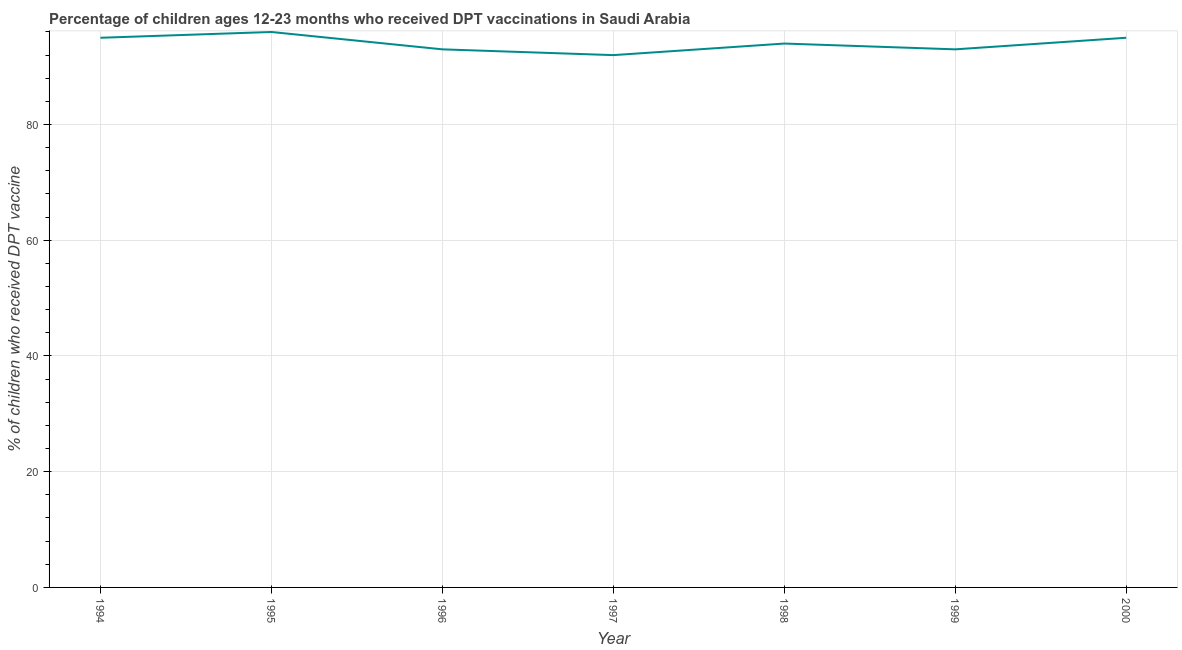What is the percentage of children who received dpt vaccine in 1998?
Your answer should be compact. 94. Across all years, what is the maximum percentage of children who received dpt vaccine?
Your answer should be compact. 96. Across all years, what is the minimum percentage of children who received dpt vaccine?
Provide a succinct answer. 92. In which year was the percentage of children who received dpt vaccine maximum?
Your answer should be compact. 1995. What is the sum of the percentage of children who received dpt vaccine?
Offer a very short reply. 658. What is the difference between the percentage of children who received dpt vaccine in 1994 and 1998?
Give a very brief answer. 1. What is the average percentage of children who received dpt vaccine per year?
Your answer should be compact. 94. What is the median percentage of children who received dpt vaccine?
Provide a succinct answer. 94. What is the ratio of the percentage of children who received dpt vaccine in 1998 to that in 1999?
Your answer should be very brief. 1.01. Is the difference between the percentage of children who received dpt vaccine in 1996 and 1999 greater than the difference between any two years?
Your answer should be very brief. No. Is the sum of the percentage of children who received dpt vaccine in 1995 and 1999 greater than the maximum percentage of children who received dpt vaccine across all years?
Your answer should be compact. Yes. What is the difference between the highest and the lowest percentage of children who received dpt vaccine?
Offer a terse response. 4. How many years are there in the graph?
Make the answer very short. 7. Does the graph contain grids?
Give a very brief answer. Yes. What is the title of the graph?
Ensure brevity in your answer.  Percentage of children ages 12-23 months who received DPT vaccinations in Saudi Arabia. What is the label or title of the Y-axis?
Ensure brevity in your answer.  % of children who received DPT vaccine. What is the % of children who received DPT vaccine of 1994?
Offer a terse response. 95. What is the % of children who received DPT vaccine of 1995?
Offer a terse response. 96. What is the % of children who received DPT vaccine in 1996?
Provide a succinct answer. 93. What is the % of children who received DPT vaccine of 1997?
Keep it short and to the point. 92. What is the % of children who received DPT vaccine in 1998?
Keep it short and to the point. 94. What is the % of children who received DPT vaccine of 1999?
Provide a succinct answer. 93. What is the difference between the % of children who received DPT vaccine in 1994 and 1996?
Your response must be concise. 2. What is the difference between the % of children who received DPT vaccine in 1994 and 1998?
Make the answer very short. 1. What is the difference between the % of children who received DPT vaccine in 1994 and 2000?
Ensure brevity in your answer.  0. What is the difference between the % of children who received DPT vaccine in 1995 and 1996?
Keep it short and to the point. 3. What is the difference between the % of children who received DPT vaccine in 1995 and 1998?
Ensure brevity in your answer.  2. What is the difference between the % of children who received DPT vaccine in 1995 and 2000?
Keep it short and to the point. 1. What is the difference between the % of children who received DPT vaccine in 1996 and 1997?
Provide a succinct answer. 1. What is the difference between the % of children who received DPT vaccine in 1996 and 1999?
Make the answer very short. 0. What is the difference between the % of children who received DPT vaccine in 1997 and 2000?
Give a very brief answer. -3. What is the difference between the % of children who received DPT vaccine in 1998 and 1999?
Provide a short and direct response. 1. What is the difference between the % of children who received DPT vaccine in 1999 and 2000?
Keep it short and to the point. -2. What is the ratio of the % of children who received DPT vaccine in 1994 to that in 1995?
Keep it short and to the point. 0.99. What is the ratio of the % of children who received DPT vaccine in 1994 to that in 1997?
Ensure brevity in your answer.  1.03. What is the ratio of the % of children who received DPT vaccine in 1995 to that in 1996?
Give a very brief answer. 1.03. What is the ratio of the % of children who received DPT vaccine in 1995 to that in 1997?
Keep it short and to the point. 1.04. What is the ratio of the % of children who received DPT vaccine in 1995 to that in 1998?
Offer a very short reply. 1.02. What is the ratio of the % of children who received DPT vaccine in 1995 to that in 1999?
Ensure brevity in your answer.  1.03. What is the ratio of the % of children who received DPT vaccine in 1996 to that in 1997?
Make the answer very short. 1.01. What is the ratio of the % of children who received DPT vaccine in 1996 to that in 1999?
Give a very brief answer. 1. What is the ratio of the % of children who received DPT vaccine in 1997 to that in 1998?
Provide a short and direct response. 0.98. What is the ratio of the % of children who received DPT vaccine in 1997 to that in 1999?
Keep it short and to the point. 0.99. What is the ratio of the % of children who received DPT vaccine in 1998 to that in 1999?
Make the answer very short. 1.01. What is the ratio of the % of children who received DPT vaccine in 1998 to that in 2000?
Give a very brief answer. 0.99. 